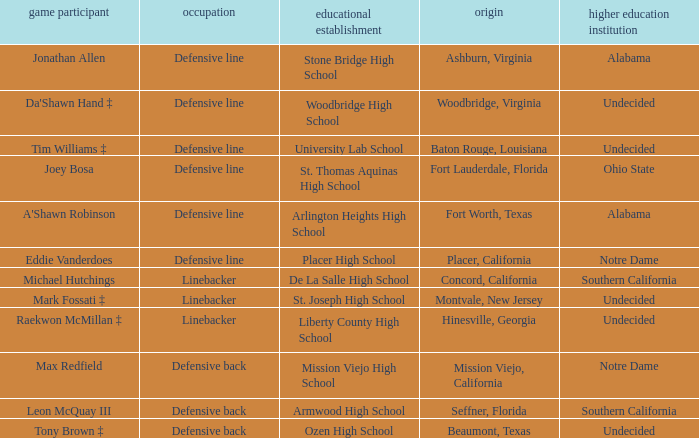What position did Max Redfield play? Defensive back. 